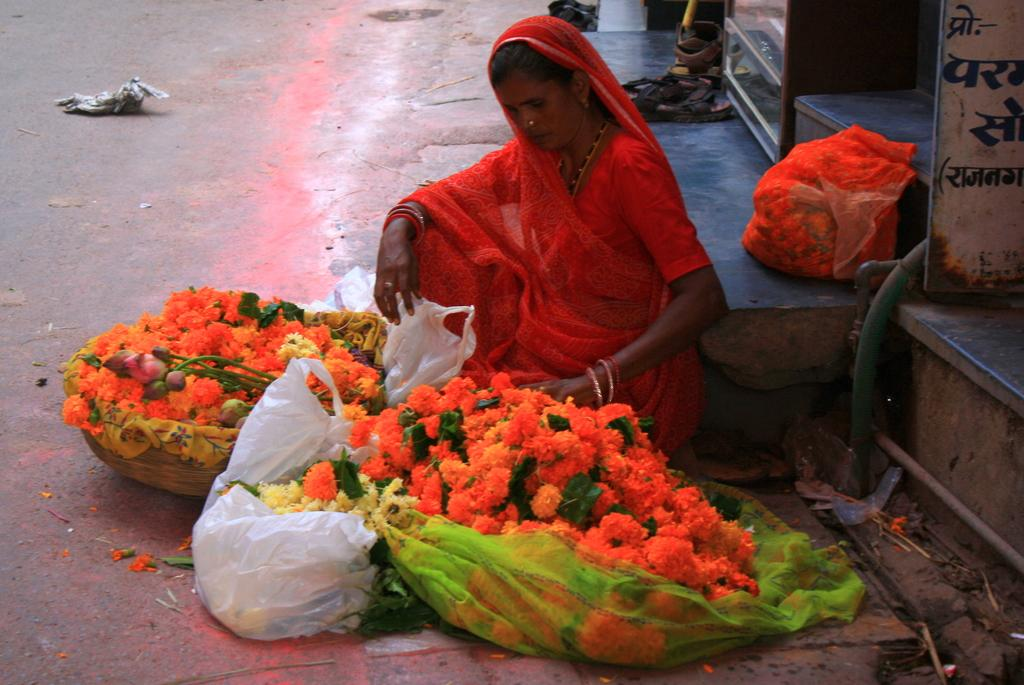Who is present in the image? There is a lady in the image. What is the lady doing in the image? The lady is sitting on the floor. What object can be seen in the image besides the lady? There is a basket in the image. What is inside the basket? The basket contains a cover. What is on the cover? The cover has flowers in it. Are there any other flowers visible in the image? Yes, there is a pack of flowers behind the basket. What amusement park can be seen in the background of the image? There is no amusement park visible in the image; it features a lady sitting on the floor with a basket and flowers. 